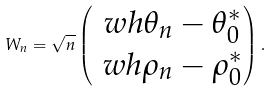<formula> <loc_0><loc_0><loc_500><loc_500>W _ { n } = \sqrt { n } \begin{pmatrix} \ w h { \theta } _ { n } - \theta ^ { * } _ { 0 } \\ \ w h { \rho } _ { n } - \rho ^ { * } _ { 0 } \end{pmatrix} .</formula> 